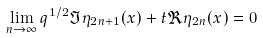<formula> <loc_0><loc_0><loc_500><loc_500>\lim _ { n \to \infty } q ^ { 1 / 2 } \Im \eta _ { 2 n + 1 } ( x ) + t \Re \eta _ { 2 n } ( x ) = 0</formula> 